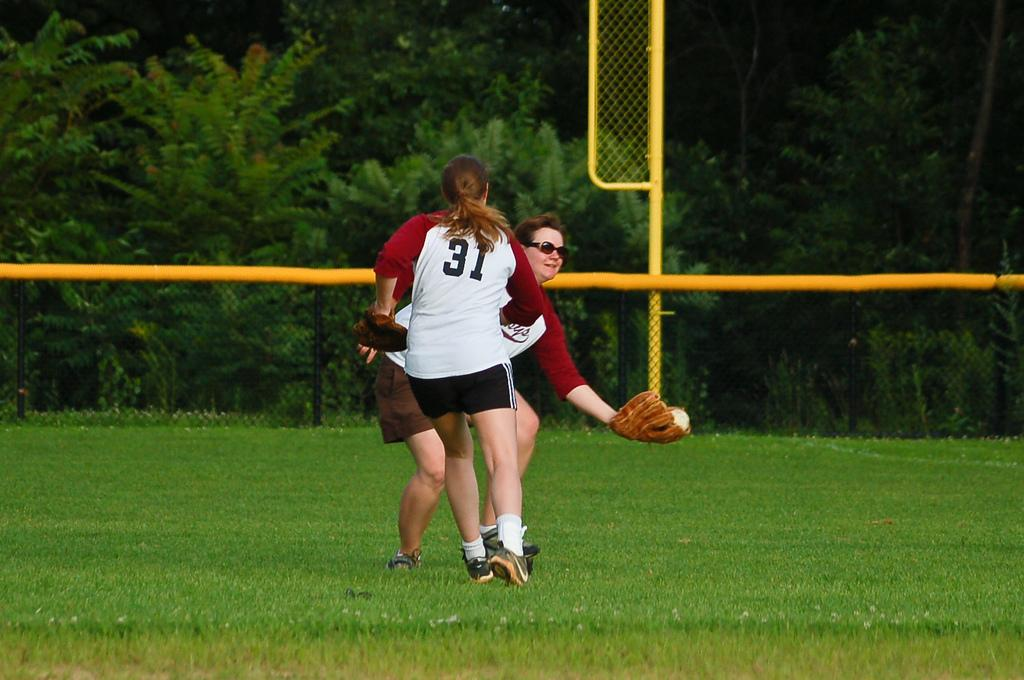<image>
Give a short and clear explanation of the subsequent image. The girl with the number 31 on her shirt runs towards another player catching a baseball. 